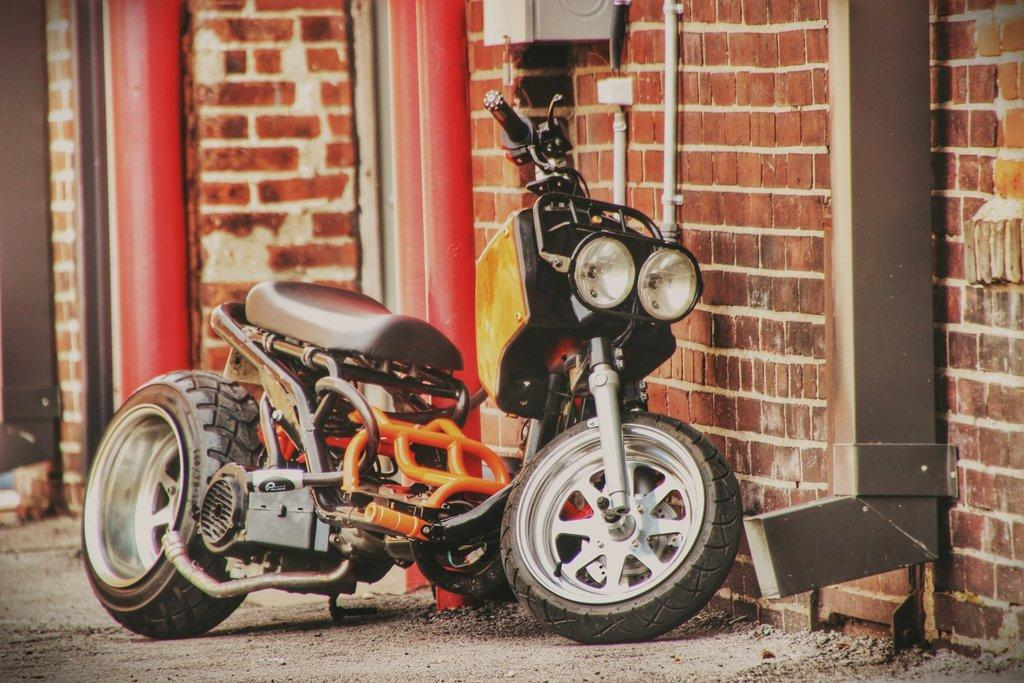What is the main subject of the picture? The main subject of the picture is a motorbike. What can be seen in the background of the picture? There is a building in the background of the picture. What is attached to the wall in the picture? There are pipes on the wall in the picture. What type of terrain is visible at the bottom of the picture? There is land visible at the bottom of the picture. What unit of measurement is used to determine the chance of the edge of the motorbike being damaged? There is no mention of any unit of measurement, chance, or damage to the motorbike in the image. 